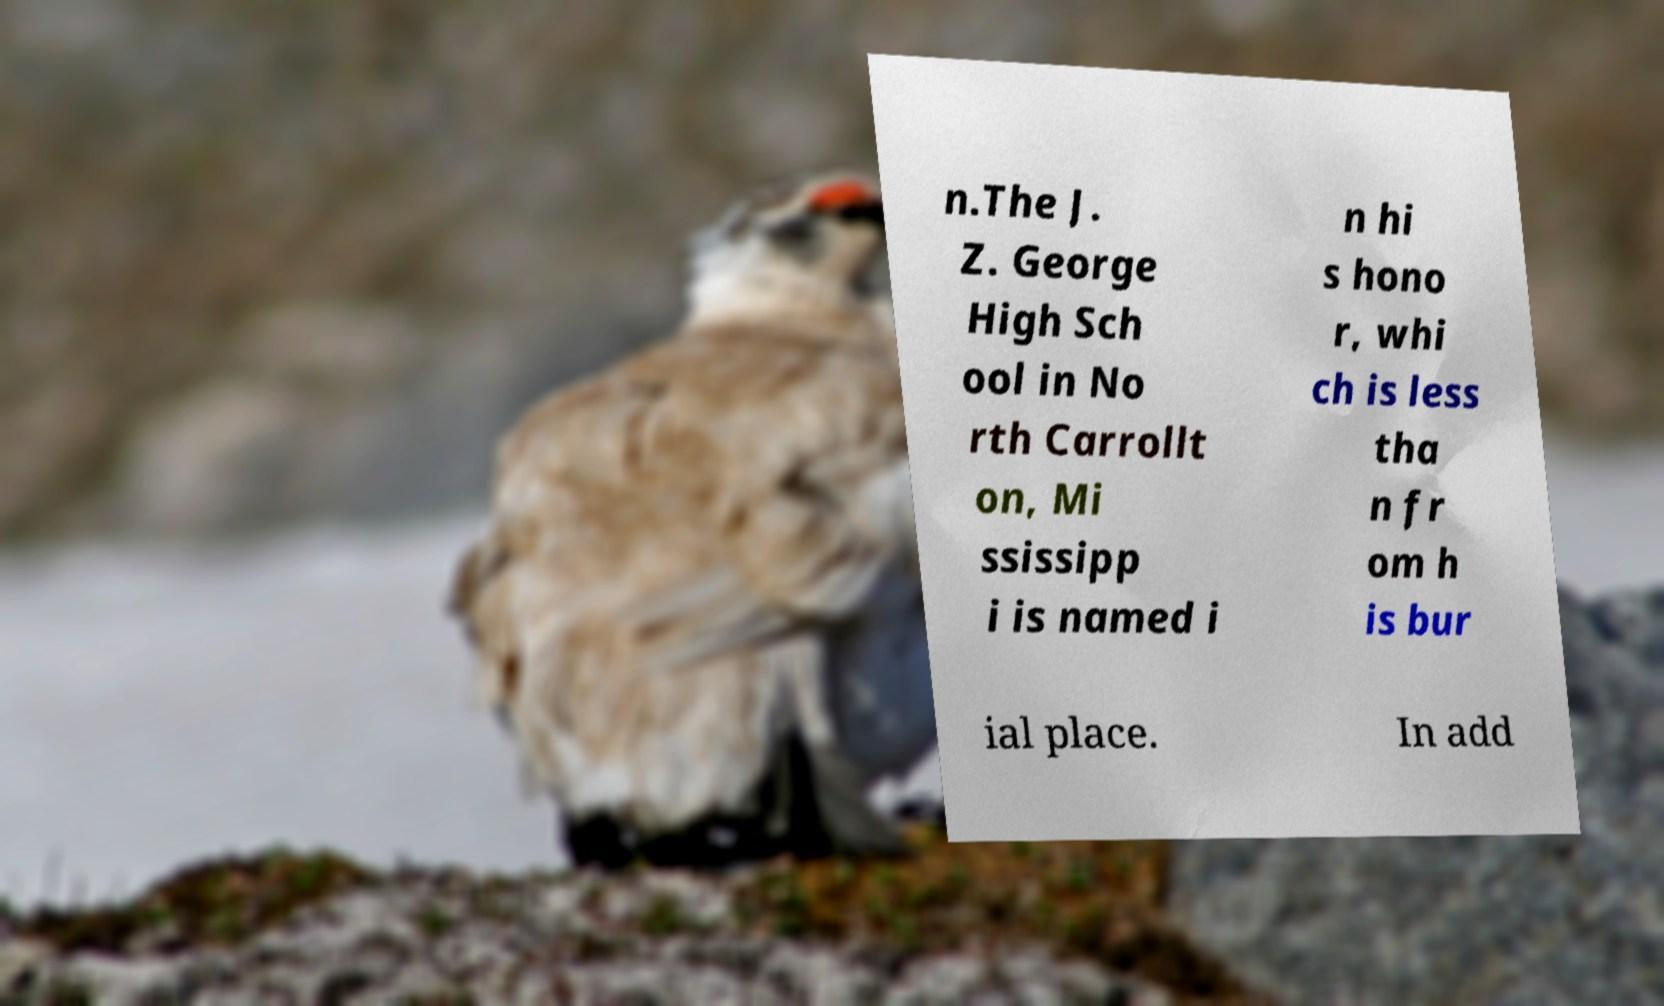There's text embedded in this image that I need extracted. Can you transcribe it verbatim? n.The J. Z. George High Sch ool in No rth Carrollt on, Mi ssissipp i is named i n hi s hono r, whi ch is less tha n fr om h is bur ial place. In add 